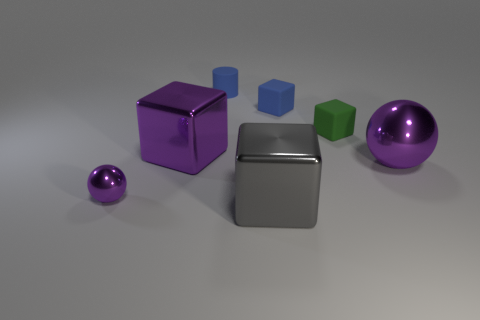Is the large metal sphere the same color as the tiny sphere?
Offer a terse response. Yes. Is the number of blue matte things that are in front of the green thing less than the number of small objects?
Provide a short and direct response. Yes. Is the material of the small blue cube the same as the cylinder behind the large metallic ball?
Provide a short and direct response. Yes. What is the tiny blue cylinder made of?
Your answer should be compact. Rubber. There is a large block that is in front of the metallic ball that is in front of the purple shiny ball that is behind the tiny purple metal sphere; what is its material?
Provide a short and direct response. Metal. There is a tiny metallic ball; does it have the same color as the large shiny thing that is behind the large metal ball?
Make the answer very short. Yes. What color is the metallic cube that is behind the large object in front of the small purple metallic thing?
Your answer should be very brief. Purple. What number of big red matte spheres are there?
Provide a succinct answer. 0. What number of rubber objects are brown cylinders or big purple spheres?
Give a very brief answer. 0. How many tiny shiny things are the same color as the big ball?
Your answer should be compact. 1. 